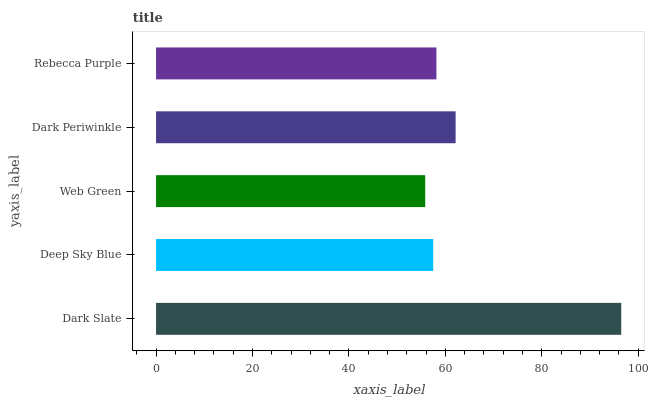Is Web Green the minimum?
Answer yes or no. Yes. Is Dark Slate the maximum?
Answer yes or no. Yes. Is Deep Sky Blue the minimum?
Answer yes or no. No. Is Deep Sky Blue the maximum?
Answer yes or no. No. Is Dark Slate greater than Deep Sky Blue?
Answer yes or no. Yes. Is Deep Sky Blue less than Dark Slate?
Answer yes or no. Yes. Is Deep Sky Blue greater than Dark Slate?
Answer yes or no. No. Is Dark Slate less than Deep Sky Blue?
Answer yes or no. No. Is Rebecca Purple the high median?
Answer yes or no. Yes. Is Rebecca Purple the low median?
Answer yes or no. Yes. Is Web Green the high median?
Answer yes or no. No. Is Dark Slate the low median?
Answer yes or no. No. 